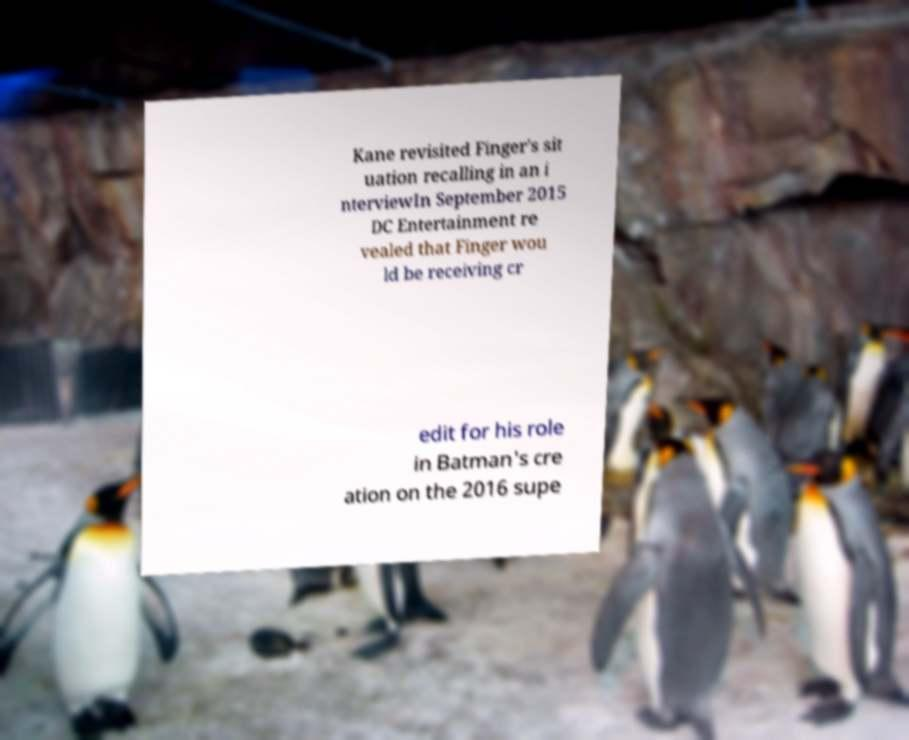Can you read and provide the text displayed in the image?This photo seems to have some interesting text. Can you extract and type it out for me? Kane revisited Finger's sit uation recalling in an i nterviewIn September 2015 DC Entertainment re vealed that Finger wou ld be receiving cr edit for his role in Batman's cre ation on the 2016 supe 